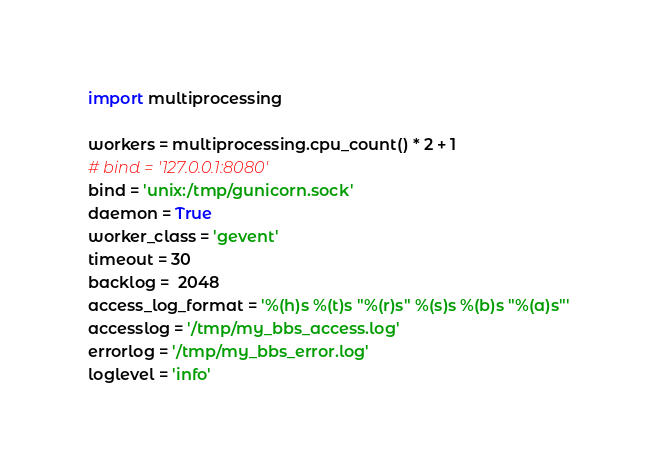Convert code to text. <code><loc_0><loc_0><loc_500><loc_500><_Python_>import multiprocessing

workers = multiprocessing.cpu_count() * 2 + 1
# bind = '127.0.0.1:8080'
bind = 'unix:/tmp/gunicorn.sock'
daemon = True
worker_class = 'gevent'
timeout = 30
backlog =  2048
access_log_format = '%(h)s %(t)s "%(r)s" %(s)s %(b)s "%(a)s"'
accesslog = '/tmp/my_bbs_access.log'
errorlog = '/tmp/my_bbs_error.log'
loglevel = 'info'
</code> 